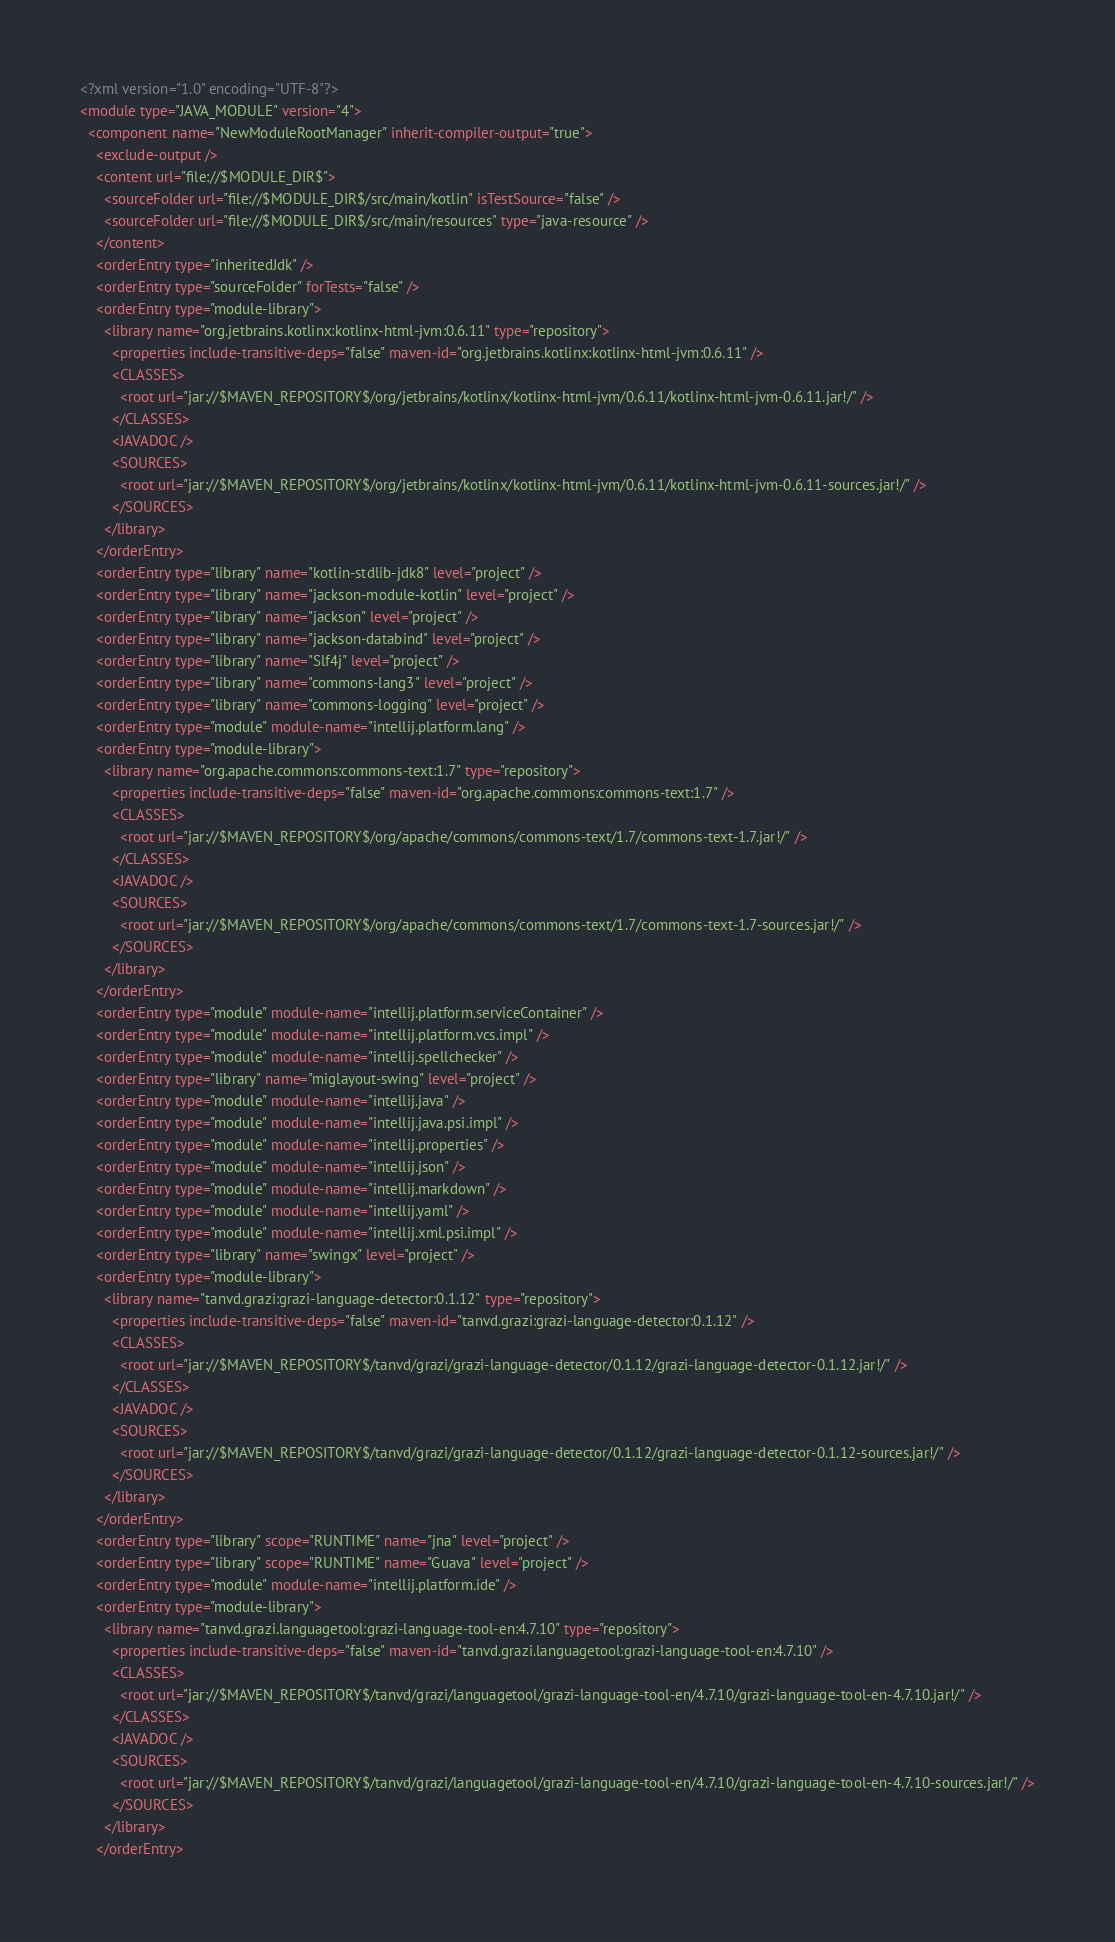<code> <loc_0><loc_0><loc_500><loc_500><_XML_><?xml version="1.0" encoding="UTF-8"?>
<module type="JAVA_MODULE" version="4">
  <component name="NewModuleRootManager" inherit-compiler-output="true">
    <exclude-output />
    <content url="file://$MODULE_DIR$">
      <sourceFolder url="file://$MODULE_DIR$/src/main/kotlin" isTestSource="false" />
      <sourceFolder url="file://$MODULE_DIR$/src/main/resources" type="java-resource" />
    </content>
    <orderEntry type="inheritedJdk" />
    <orderEntry type="sourceFolder" forTests="false" />
    <orderEntry type="module-library">
      <library name="org.jetbrains.kotlinx:kotlinx-html-jvm:0.6.11" type="repository">
        <properties include-transitive-deps="false" maven-id="org.jetbrains.kotlinx:kotlinx-html-jvm:0.6.11" />
        <CLASSES>
          <root url="jar://$MAVEN_REPOSITORY$/org/jetbrains/kotlinx/kotlinx-html-jvm/0.6.11/kotlinx-html-jvm-0.6.11.jar!/" />
        </CLASSES>
        <JAVADOC />
        <SOURCES>
          <root url="jar://$MAVEN_REPOSITORY$/org/jetbrains/kotlinx/kotlinx-html-jvm/0.6.11/kotlinx-html-jvm-0.6.11-sources.jar!/" />
        </SOURCES>
      </library>
    </orderEntry>
    <orderEntry type="library" name="kotlin-stdlib-jdk8" level="project" />
    <orderEntry type="library" name="jackson-module-kotlin" level="project" />
    <orderEntry type="library" name="jackson" level="project" />
    <orderEntry type="library" name="jackson-databind" level="project" />
    <orderEntry type="library" name="Slf4j" level="project" />
    <orderEntry type="library" name="commons-lang3" level="project" />
    <orderEntry type="library" name="commons-logging" level="project" />
    <orderEntry type="module" module-name="intellij.platform.lang" />
    <orderEntry type="module-library">
      <library name="org.apache.commons:commons-text:1.7" type="repository">
        <properties include-transitive-deps="false" maven-id="org.apache.commons:commons-text:1.7" />
        <CLASSES>
          <root url="jar://$MAVEN_REPOSITORY$/org/apache/commons/commons-text/1.7/commons-text-1.7.jar!/" />
        </CLASSES>
        <JAVADOC />
        <SOURCES>
          <root url="jar://$MAVEN_REPOSITORY$/org/apache/commons/commons-text/1.7/commons-text-1.7-sources.jar!/" />
        </SOURCES>
      </library>
    </orderEntry>
    <orderEntry type="module" module-name="intellij.platform.serviceContainer" />
    <orderEntry type="module" module-name="intellij.platform.vcs.impl" />
    <orderEntry type="module" module-name="intellij.spellchecker" />
    <orderEntry type="library" name="miglayout-swing" level="project" />
    <orderEntry type="module" module-name="intellij.java" />
    <orderEntry type="module" module-name="intellij.java.psi.impl" />
    <orderEntry type="module" module-name="intellij.properties" />
    <orderEntry type="module" module-name="intellij.json" />
    <orderEntry type="module" module-name="intellij.markdown" />
    <orderEntry type="module" module-name="intellij.yaml" />
    <orderEntry type="module" module-name="intellij.xml.psi.impl" />
    <orderEntry type="library" name="swingx" level="project" />
    <orderEntry type="module-library">
      <library name="tanvd.grazi:grazi-language-detector:0.1.12" type="repository">
        <properties include-transitive-deps="false" maven-id="tanvd.grazi:grazi-language-detector:0.1.12" />
        <CLASSES>
          <root url="jar://$MAVEN_REPOSITORY$/tanvd/grazi/grazi-language-detector/0.1.12/grazi-language-detector-0.1.12.jar!/" />
        </CLASSES>
        <JAVADOC />
        <SOURCES>
          <root url="jar://$MAVEN_REPOSITORY$/tanvd/grazi/grazi-language-detector/0.1.12/grazi-language-detector-0.1.12-sources.jar!/" />
        </SOURCES>
      </library>
    </orderEntry>
    <orderEntry type="library" scope="RUNTIME" name="jna" level="project" />
    <orderEntry type="library" scope="RUNTIME" name="Guava" level="project" />
    <orderEntry type="module" module-name="intellij.platform.ide" />
    <orderEntry type="module-library">
      <library name="tanvd.grazi.languagetool:grazi-language-tool-en:4.7.10" type="repository">
        <properties include-transitive-deps="false" maven-id="tanvd.grazi.languagetool:grazi-language-tool-en:4.7.10" />
        <CLASSES>
          <root url="jar://$MAVEN_REPOSITORY$/tanvd/grazi/languagetool/grazi-language-tool-en/4.7.10/grazi-language-tool-en-4.7.10.jar!/" />
        </CLASSES>
        <JAVADOC />
        <SOURCES>
          <root url="jar://$MAVEN_REPOSITORY$/tanvd/grazi/languagetool/grazi-language-tool-en/4.7.10/grazi-language-tool-en-4.7.10-sources.jar!/" />
        </SOURCES>
      </library>
    </orderEntry></code> 